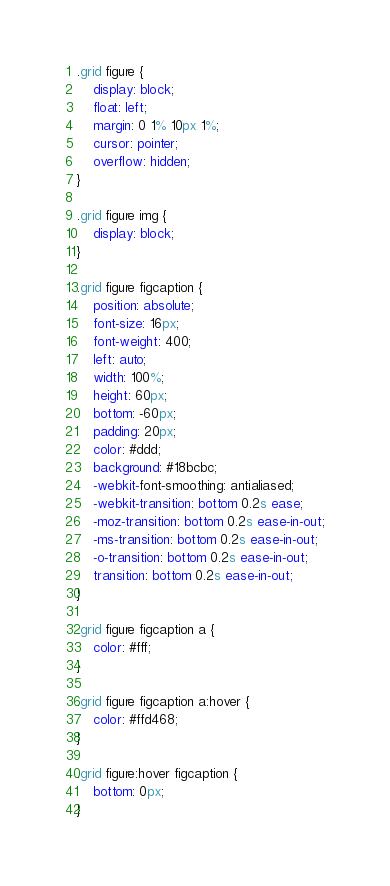Convert code to text. <code><loc_0><loc_0><loc_500><loc_500><_CSS_>
.grid figure {
	display: block;
	float: left;
	margin: 0 1% 10px 1%;
	cursor: pointer;
	overflow: hidden;
}

.grid figure img {
	display: block;
}

.grid figure figcaption {
	position: absolute;
	font-size: 16px;
	font-weight: 400;
	left: auto;
	width: 100%;
	height: 60px;
	bottom: -60px;
	padding: 20px;
	color: #ddd;
	background: #18bcbc;
	-webkit-font-smoothing: antialiased;
	-webkit-transition: bottom 0.2s ease;
	-moz-transition: bottom 0.2s ease-in-out;
	-ms-transition: bottom 0.2s ease-in-out;
	-o-transition: bottom 0.2s ease-in-out;
	transition: bottom 0.2s ease-in-out;
}

.grid figure figcaption a {
	color: #fff;
}

.grid figure figcaption a:hover {
	color: #ffd468;
}

.grid figure:hover figcaption {
	bottom: 0px;
}


</code> 